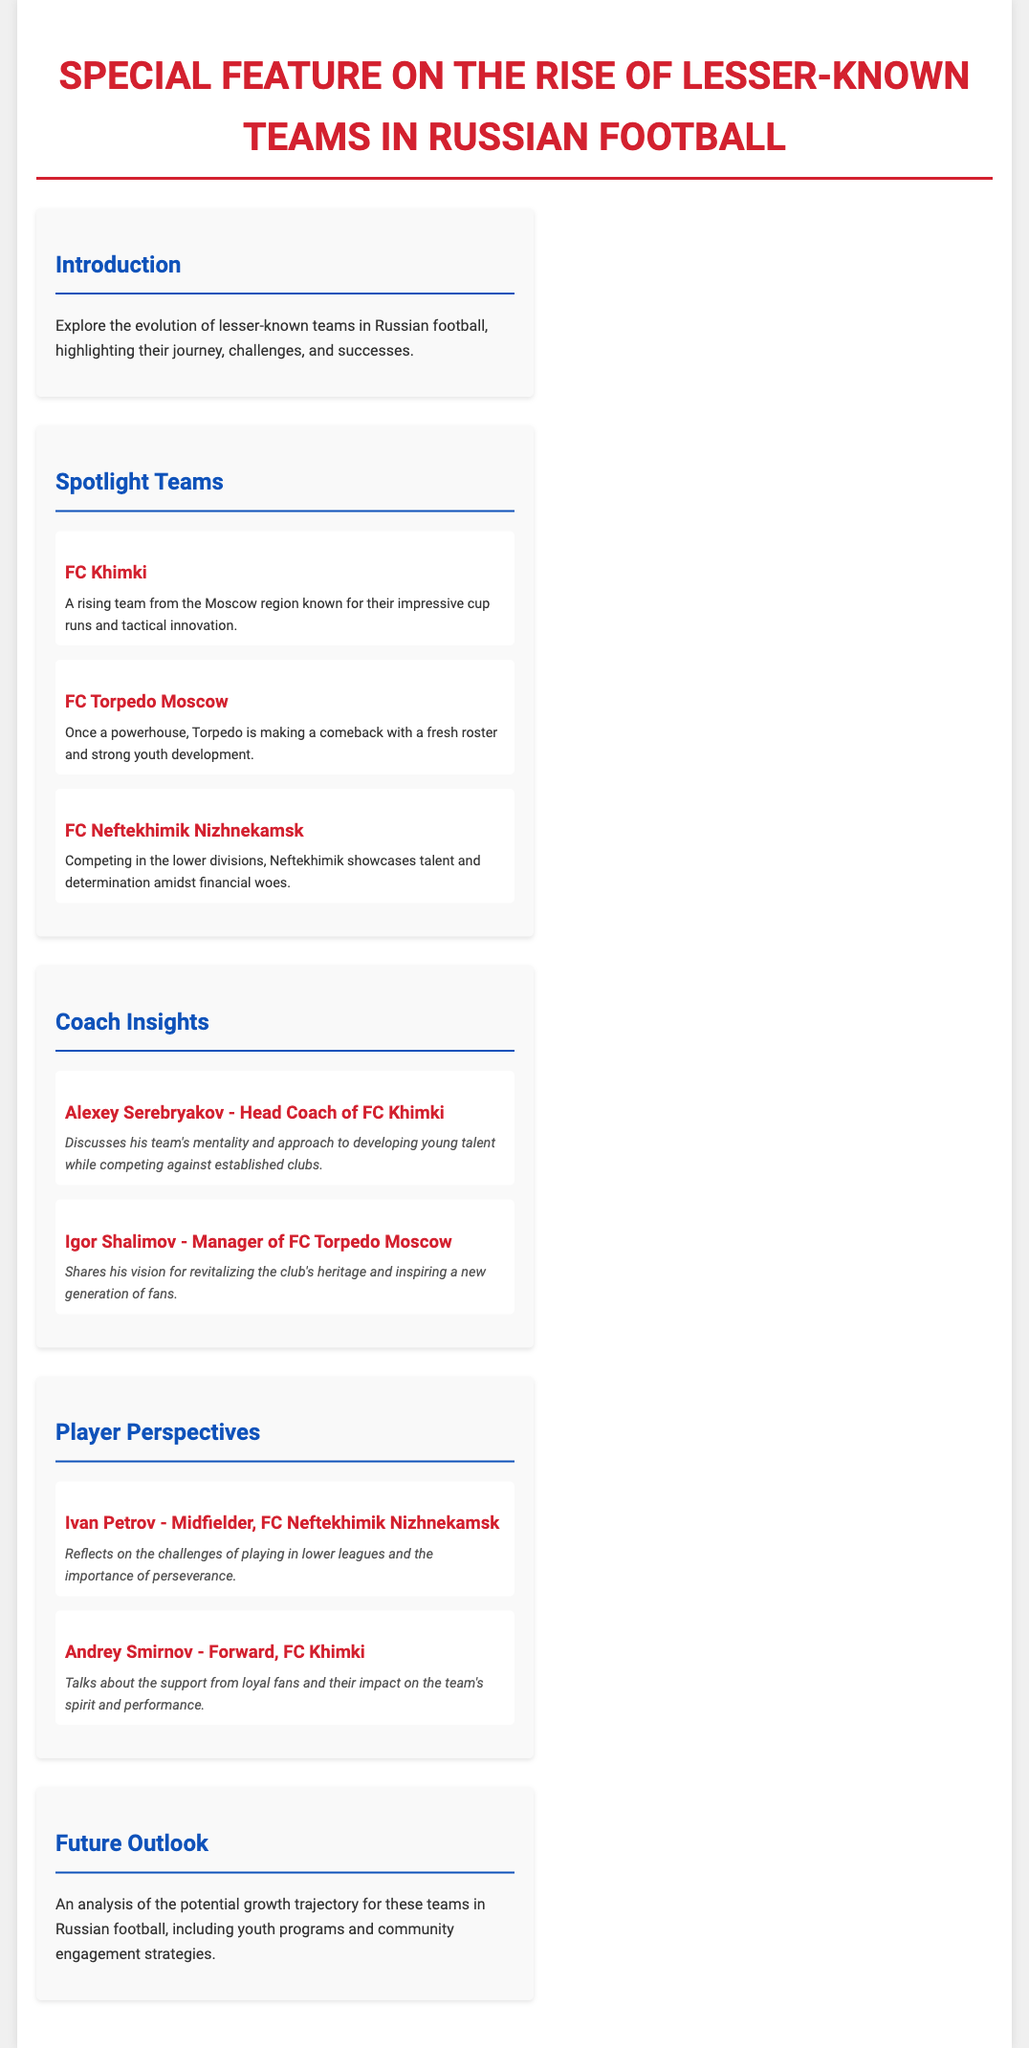What is the title of the document? The title is prominently displayed at the top of the document, indicating the main focus.
Answer: Rise of Lesser-Known Teams in Russian Football Which team is highlighted as a rising team from the Moscow region? The document specifically mentions a team from the Moscow region that has gained attention for its achievements.
Answer: FC Khimki Who is the head coach of FC Khimki? The document includes the name and title of the head coach in the interview section.
Answer: Alexey Serebryakov What is a main challenge faced by FC Neftekhimik Nizhnekamsk? The content describes a specific issue that the club deals with as part of its operations.
Answer: Financial woes Who shares insights on revitalizing the club's heritage? The document details insights from the managerial perspective related to club revitalization efforts.
Answer: Igor Shalimov What does Ivan Petrov reflect on in his interview? The document highlights Ivan Petrov's main focus regarding his experience as a player.
Answer: Challenges of playing in lower leagues What does the future outlook section analyze? The document outlines a specific area of growth potential related to lesser-known teams.
Answer: Potential growth trajectory How many spotlight teams are discussed in the document? The number of teams featured in the spotlight section is mentioned in the context of the content.
Answer: Three 